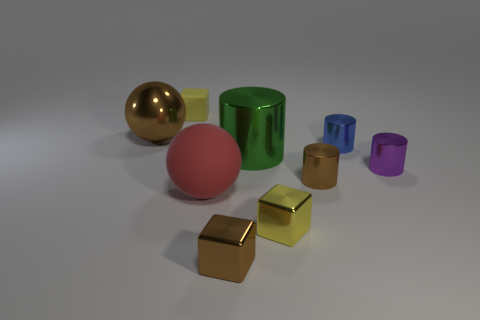What is the size of the purple thing that is made of the same material as the blue cylinder?
Offer a terse response. Small. How many yellow metallic objects are the same shape as the green metal thing?
Offer a very short reply. 0. There is a yellow object on the left side of the tiny yellow cube in front of the rubber ball; how big is it?
Give a very brief answer. Small. What is the material of the brown cylinder that is the same size as the blue shiny thing?
Your response must be concise. Metal. Are there any other blue cylinders that have the same material as the blue cylinder?
Provide a succinct answer. No. There is a large metallic object in front of the brown metal thing on the left side of the rubber block on the left side of the blue thing; what is its color?
Ensure brevity in your answer.  Green. Do the big sphere that is behind the large red matte thing and the tiny cylinder left of the blue shiny cylinder have the same color?
Keep it short and to the point. Yes. Is there anything else that is the same color as the matte cube?
Give a very brief answer. Yes. Are there fewer yellow metal cubes that are on the right side of the blue object than green shiny cylinders?
Provide a succinct answer. Yes. How many brown spheres are there?
Keep it short and to the point. 1. 